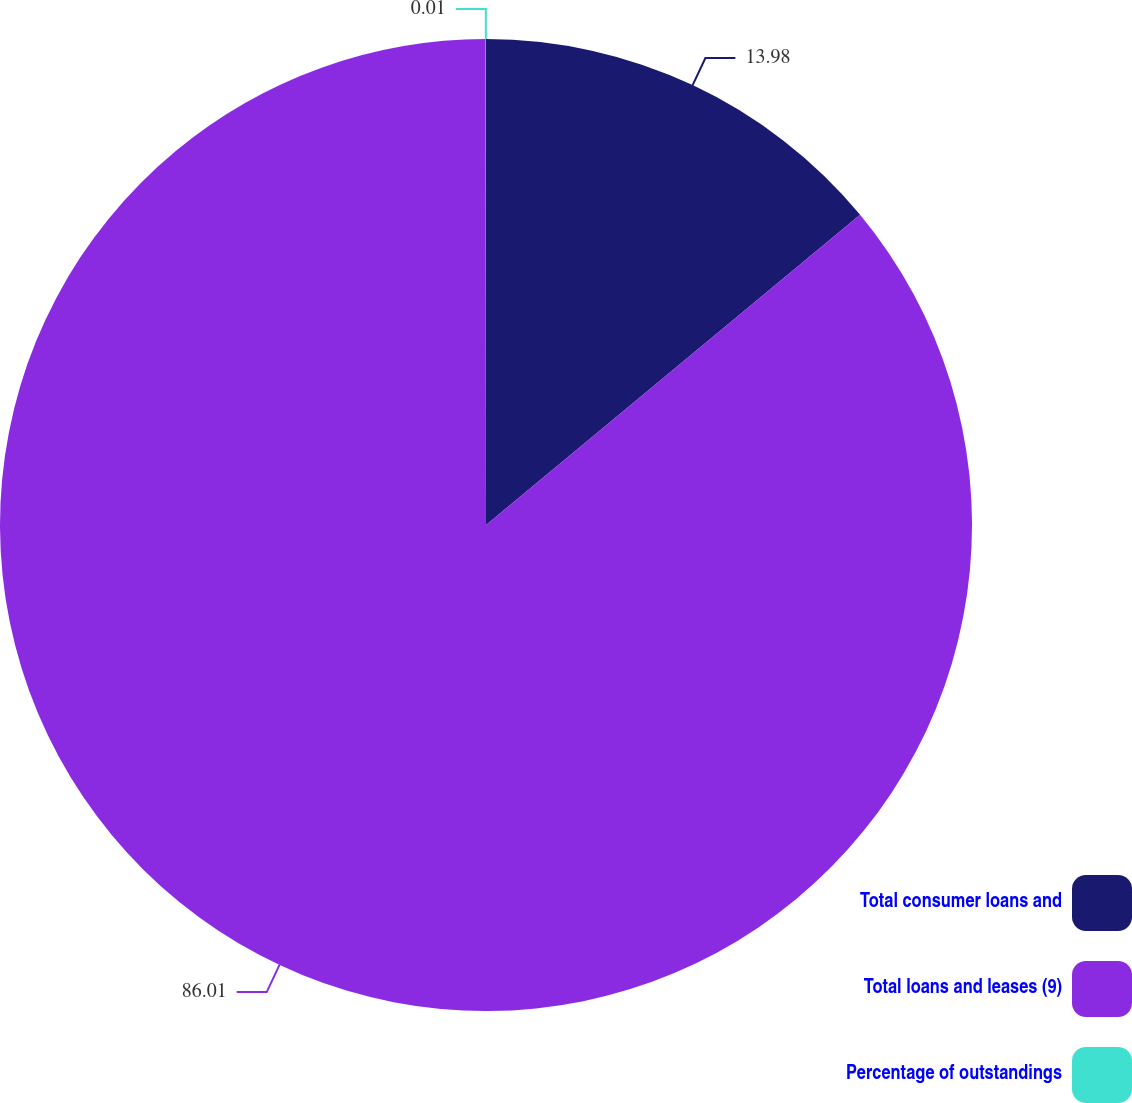Convert chart. <chart><loc_0><loc_0><loc_500><loc_500><pie_chart><fcel>Total consumer loans and<fcel>Total loans and leases (9)<fcel>Percentage of outstandings<nl><fcel>13.98%<fcel>86.01%<fcel>0.01%<nl></chart> 